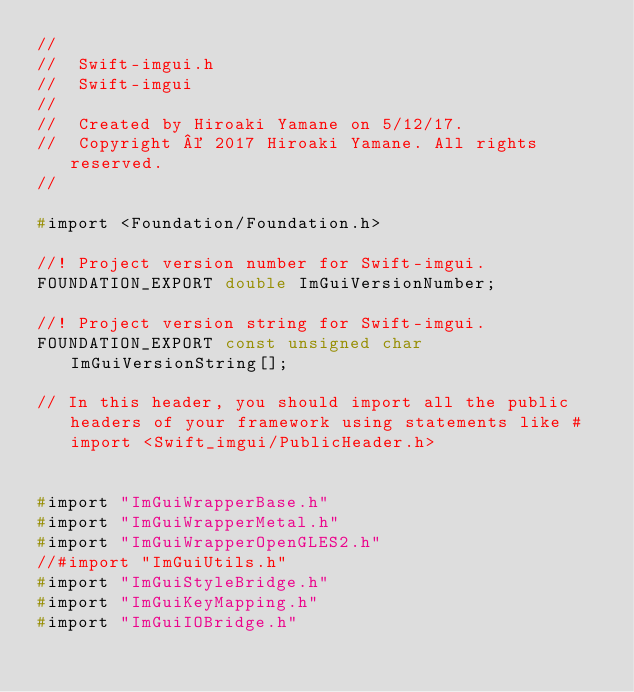Convert code to text. <code><loc_0><loc_0><loc_500><loc_500><_C_>//
//  Swift-imgui.h
//  Swift-imgui
//
//  Created by Hiroaki Yamane on 5/12/17.
//  Copyright © 2017 Hiroaki Yamane. All rights reserved.
//

#import <Foundation/Foundation.h>

//! Project version number for Swift-imgui.
FOUNDATION_EXPORT double ImGuiVersionNumber;

//! Project version string for Swift-imgui.
FOUNDATION_EXPORT const unsigned char ImGuiVersionString[];

// In this header, you should import all the public headers of your framework using statements like #import <Swift_imgui/PublicHeader.h>


#import "ImGuiWrapperBase.h"
#import "ImGuiWrapperMetal.h"
#import "ImGuiWrapperOpenGLES2.h"
//#import "ImGuiUtils.h"
#import "ImGuiStyleBridge.h"
#import "ImGuiKeyMapping.h"
#import "ImGuiIOBridge.h"
</code> 